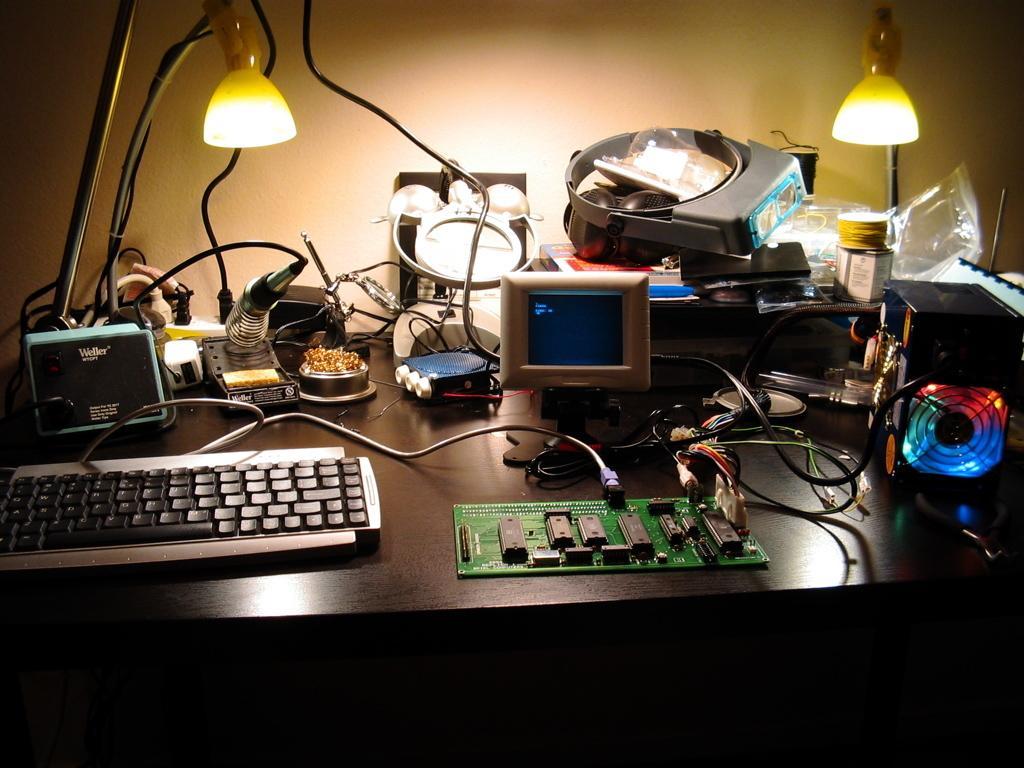Describe this image in one or two sentences. In this picture we see a table on the table we see table lamps and a keyboard and a motherboard and a small monitor 